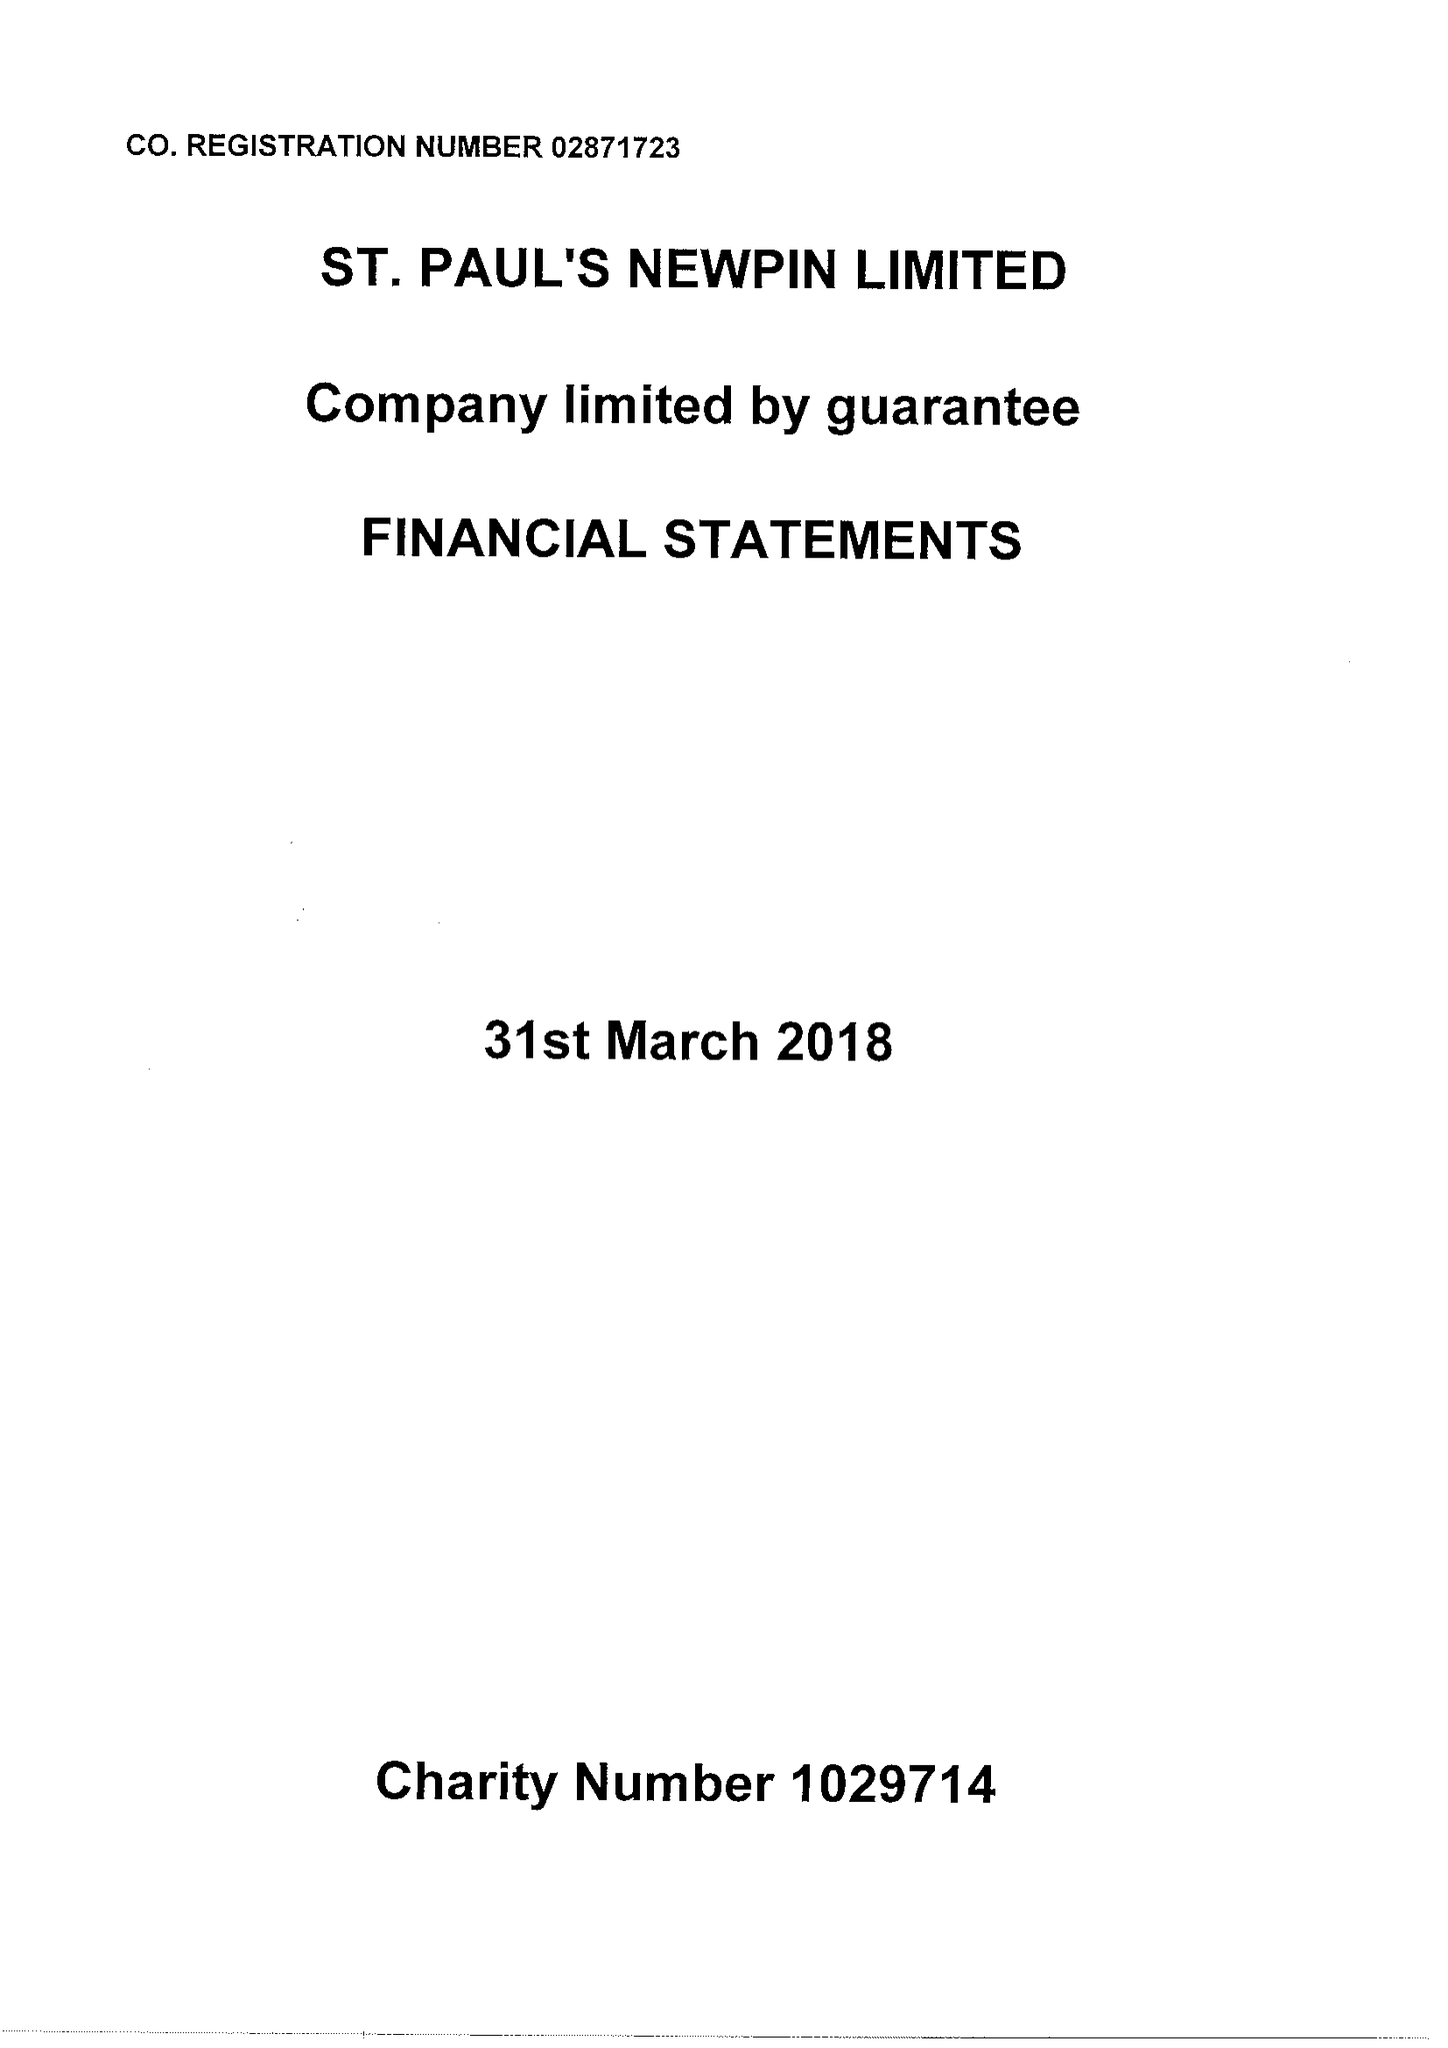What is the value for the charity_number?
Answer the question using a single word or phrase. 1029714 